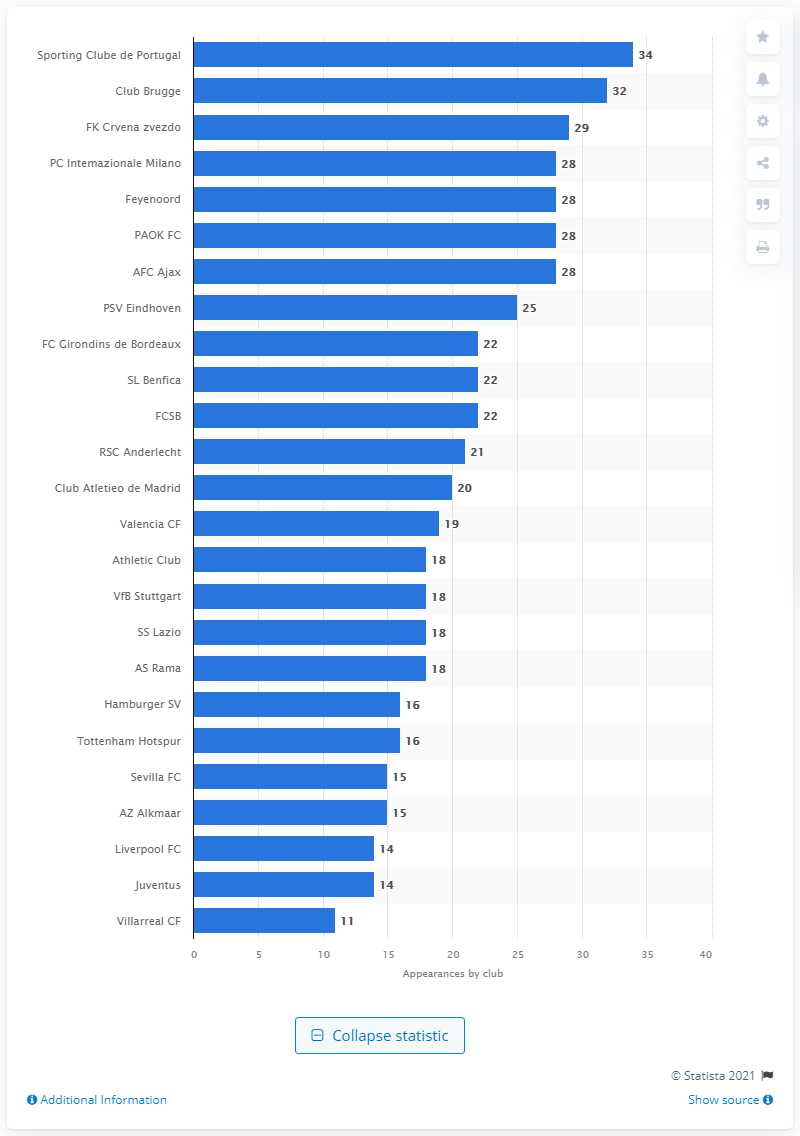Draw attention to some important aspects in this diagram. As of May 2021, Sporting Clube de Portugal had a total of 34 appearances in the UEFA Europa League. As of May 2021, Sporting Clube de Portugal had made 34 appearances in the UEFA Europa League. As of May 2021, Brugge had made 32 appearances in the UEFA Europa League. 